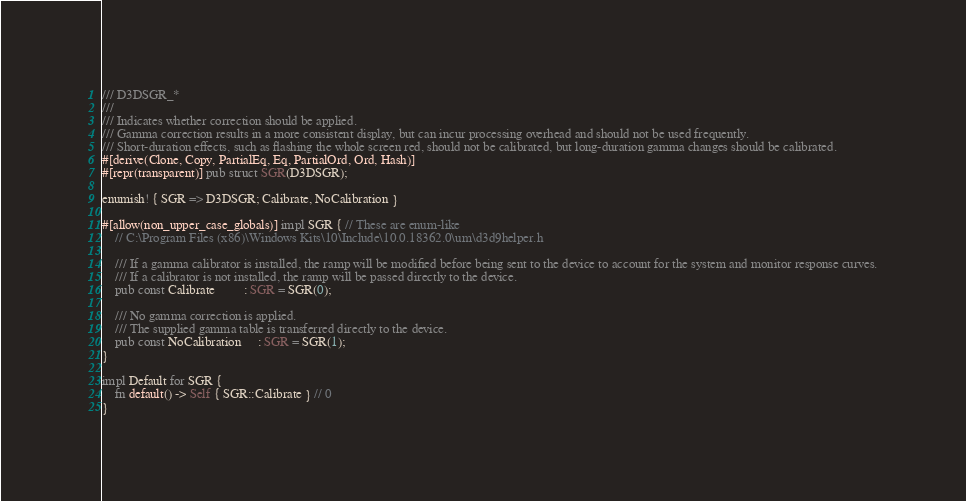Convert code to text. <code><loc_0><loc_0><loc_500><loc_500><_Rust_>/// D3DSGR_*
///
/// Indicates whether correction should be applied.
/// Gamma correction results in a more consistent display, but can incur processing overhead and should not be used frequently.
/// Short-duration effects, such as flashing the whole screen red, should not be calibrated, but long-duration gamma changes should be calibrated.
#[derive(Clone, Copy, PartialEq, Eq, PartialOrd, Ord, Hash)]
#[repr(transparent)] pub struct SGR(D3DSGR);

enumish! { SGR => D3DSGR; Calibrate, NoCalibration }

#[allow(non_upper_case_globals)] impl SGR { // These are enum-like
    // C:\Program Files (x86)\Windows Kits\10\Include\10.0.18362.0\um\d3d9helper.h

    /// If a gamma calibrator is installed, the ramp will be modified before being sent to the device to account for the system and monitor response curves.
    /// If a calibrator is not installed, the ramp will be passed directly to the device.
    pub const Calibrate         : SGR = SGR(0);

    /// No gamma correction is applied.
    /// The supplied gamma table is transferred directly to the device.
    pub const NoCalibration     : SGR = SGR(1);
}

impl Default for SGR {
    fn default() -> Self { SGR::Calibrate } // 0
}
</code> 